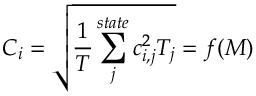Convert formula to latex. <formula><loc_0><loc_0><loc_500><loc_500>C _ { i } = \sqrt { \frac { 1 } { T } \sum _ { j } ^ { s t a t e } c _ { i , j } ^ { 2 } T _ { j } } = f ( M )</formula> 